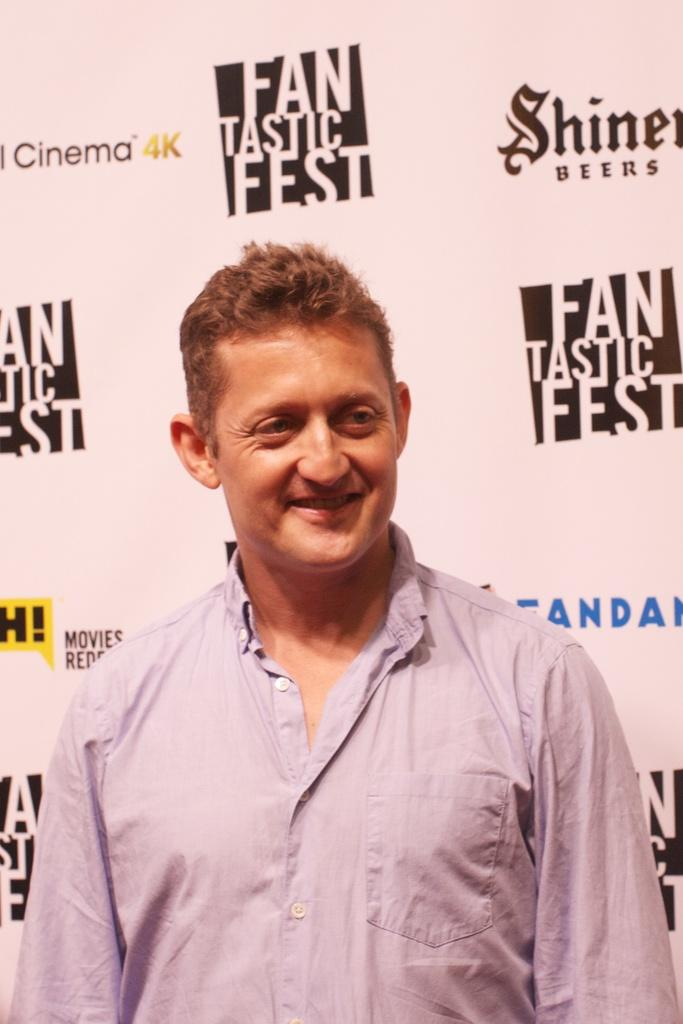Provide a one-sentence caption for the provided image. Man standing in front of a fantastic fest wallpaper. 